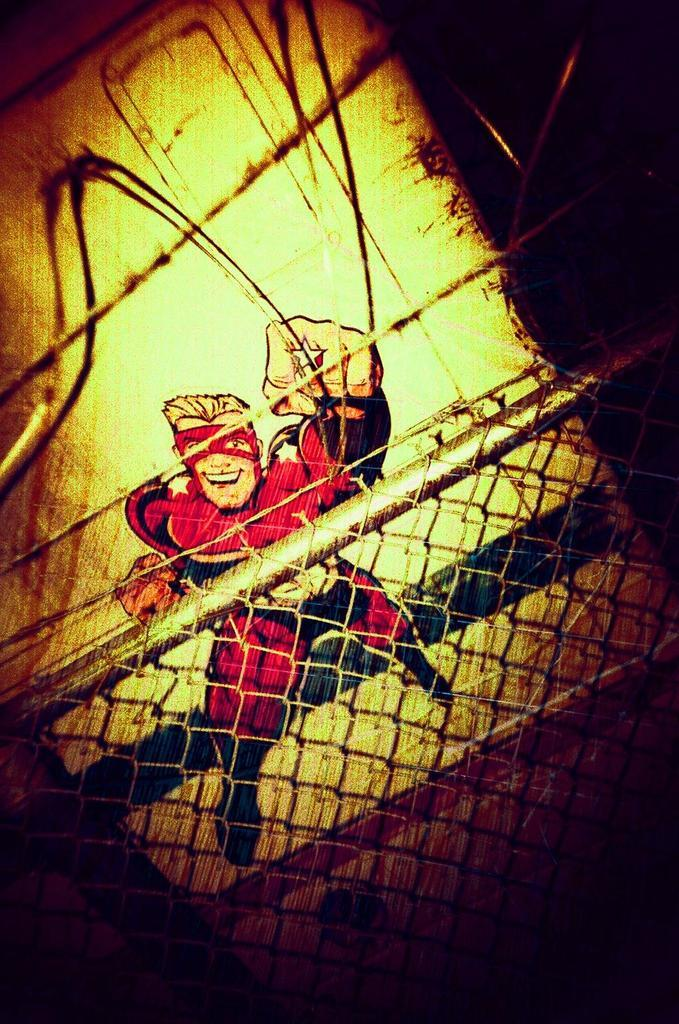What is located at the front of the image? There is a fence in the front of the image. What can be seen in the background of the image? There is a drawing of a cartoon in the background of the image. What type of creature can be seen playing in the bushes in the image? There are no bushes or creatures present in the image; it features a fence and a drawing of a cartoon in the background. 